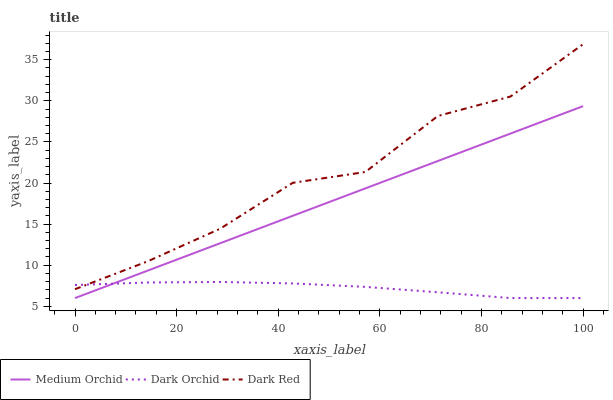Does Medium Orchid have the minimum area under the curve?
Answer yes or no. No. Does Medium Orchid have the maximum area under the curve?
Answer yes or no. No. Is Dark Orchid the smoothest?
Answer yes or no. No. Is Dark Orchid the roughest?
Answer yes or no. No. Does Medium Orchid have the highest value?
Answer yes or no. No. Is Medium Orchid less than Dark Red?
Answer yes or no. Yes. Is Dark Red greater than Medium Orchid?
Answer yes or no. Yes. Does Medium Orchid intersect Dark Red?
Answer yes or no. No. 